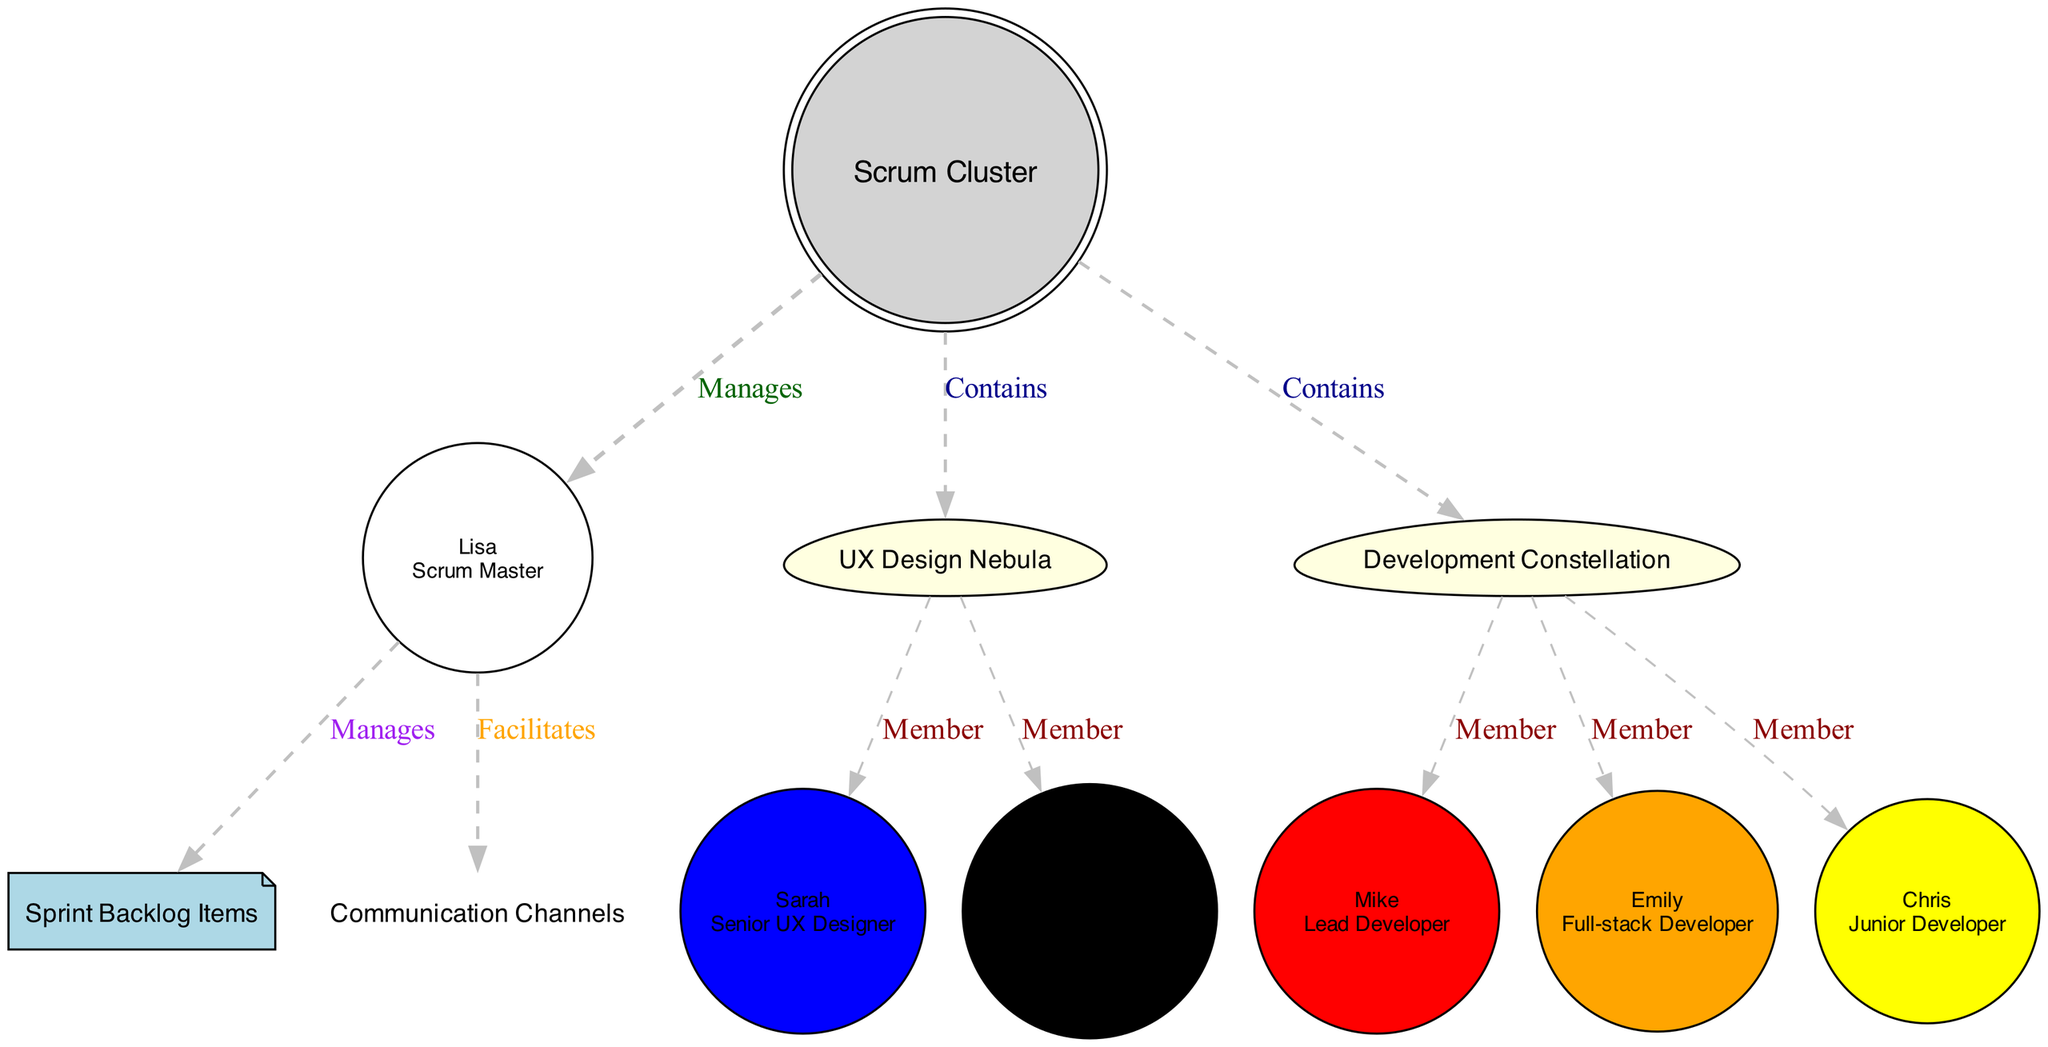What is the central galaxy represented in the diagram? The central galaxy in the diagram is labeled as "Scrum Cluster," indicating the core of the visualization.
Answer: Scrum Cluster How many star clusters are depicted in the diagram? There are two star clusters shown in the diagram: "UX Design Nebula" and "Development Constellation." Counting these gives a total of 2.
Answer: 2 What role does the star colored blue represent? The blue star represents "Senior UX Designer," as indicated by the color coding in the diagram.
Answer: Senior UX Designer What is the role of the character named Lisa? Lisa is depicted as the "Scrum Master," as stated in her label within the diagram.
Answer: Scrum Master How many members are in the "Development Constellation"? The "Development Constellation" consists of three members: Mike, Emily, and Chris. This is counted straightforwardly from the stars listed.
Answer: 3 Which color indicates a Junior Developer in the diagram? The color yellow is used to indicate a Junior Developer, represented by Chris in the diagram.
Answer: Yellow What is the function of the cosmic dust in the diagram? The cosmic dust is labeled as "Sprint Backlog Items," showing the items managed by the Scrum Master in the context of the teamwork.
Answer: Sprint Backlog Items Who manages the communication channels in the diagram? The Scrum Master, represented by Lisa, facilitates the communication channels as indicated by the labeled edge connecting to "Communication Channels."
Answer: Scrum Master What size is the star representing Sarah? The size of the star representing Sarah is labeled as "Large," indicating her significant experience level in the UX design role.
Answer: Large 